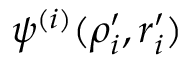Convert formula to latex. <formula><loc_0><loc_0><loc_500><loc_500>\psi ^ { ( i ) } ( \rho _ { i } ^ { \prime } , r _ { i } ^ { \prime } )</formula> 